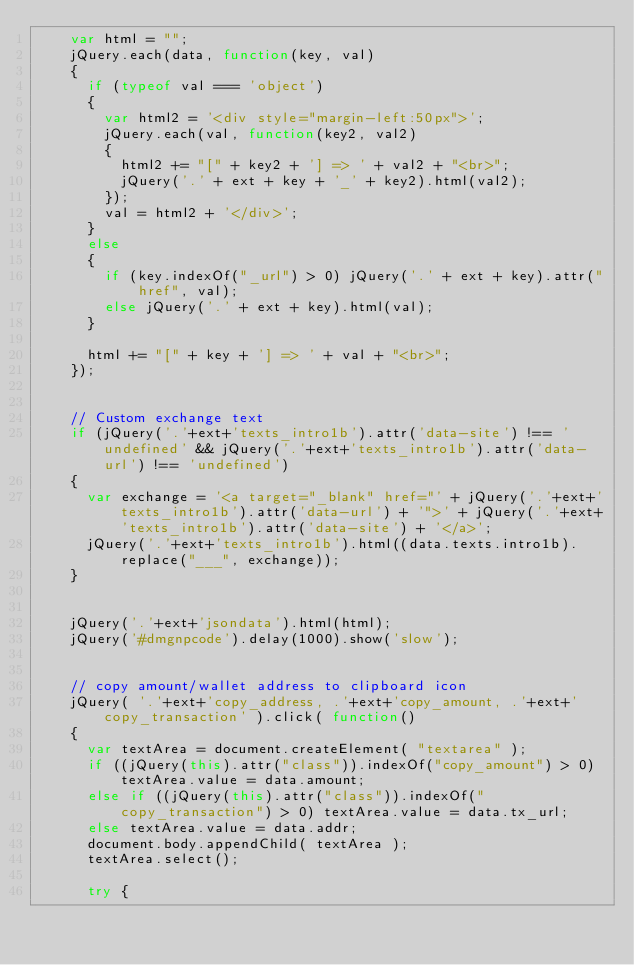<code> <loc_0><loc_0><loc_500><loc_500><_JavaScript_>		var html = "";
		jQuery.each(data, function(key, val)
		{
			if (typeof val === 'object')
			{
				var html2 = '<div style="margin-left:50px">';
				jQuery.each(val, function(key2, val2)
				{
					html2 += "[" + key2 + '] => ' + val2 + "<br>";
					jQuery('.' + ext + key + '_' + key2).html(val2);
				});
				val = html2 + '</div>';
			}
			else 
			{	
				if (key.indexOf("_url") > 0) jQuery('.' + ext + key).attr("href", val);
				else jQuery('.' + ext + key).html(val);
			}
			
			html += "[" + key + '] => ' + val + "<br>";
		});
		

		// Custom exchange text
		if (jQuery('.'+ext+'texts_intro1b').attr('data-site') !== 'undefined' && jQuery('.'+ext+'texts_intro1b').attr('data-url') !== 'undefined')
		{
			var exchange = '<a target="_blank" href="' + jQuery('.'+ext+'texts_intro1b').attr('data-url') + '">' + jQuery('.'+ext+'texts_intro1b').attr('data-site') + '</a>';
			jQuery('.'+ext+'texts_intro1b').html((data.texts.intro1b).replace("___", exchange));
		}
		

		jQuery('.'+ext+'jsondata').html(html);
		jQuery('#dmgnpcode').delay(1000).show('slow');
		
		
		// copy amount/wallet address to clipboard icon
		jQuery( '.'+ext+'copy_address, .'+ext+'copy_amount, .'+ext+'copy_transaction' ).click( function()
		{
			var textArea = document.createElement( "textarea" );
			if ((jQuery(this).attr("class")).indexOf("copy_amount") > 0) textArea.value = data.amount;
			else if ((jQuery(this).attr("class")).indexOf("copy_transaction") > 0) textArea.value = data.tx_url;
			else textArea.value = data.addr;
			document.body.appendChild( textArea );
			textArea.select();
			
			try {</code> 